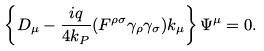Convert formula to latex. <formula><loc_0><loc_0><loc_500><loc_500>\left \{ D _ { \mu } - \frac { i q } { 4 k _ { P } } ( F ^ { \rho \sigma } \gamma _ { \rho } \gamma _ { \sigma } ) k _ { \mu } \right \} \Psi ^ { \mu } = 0 .</formula> 